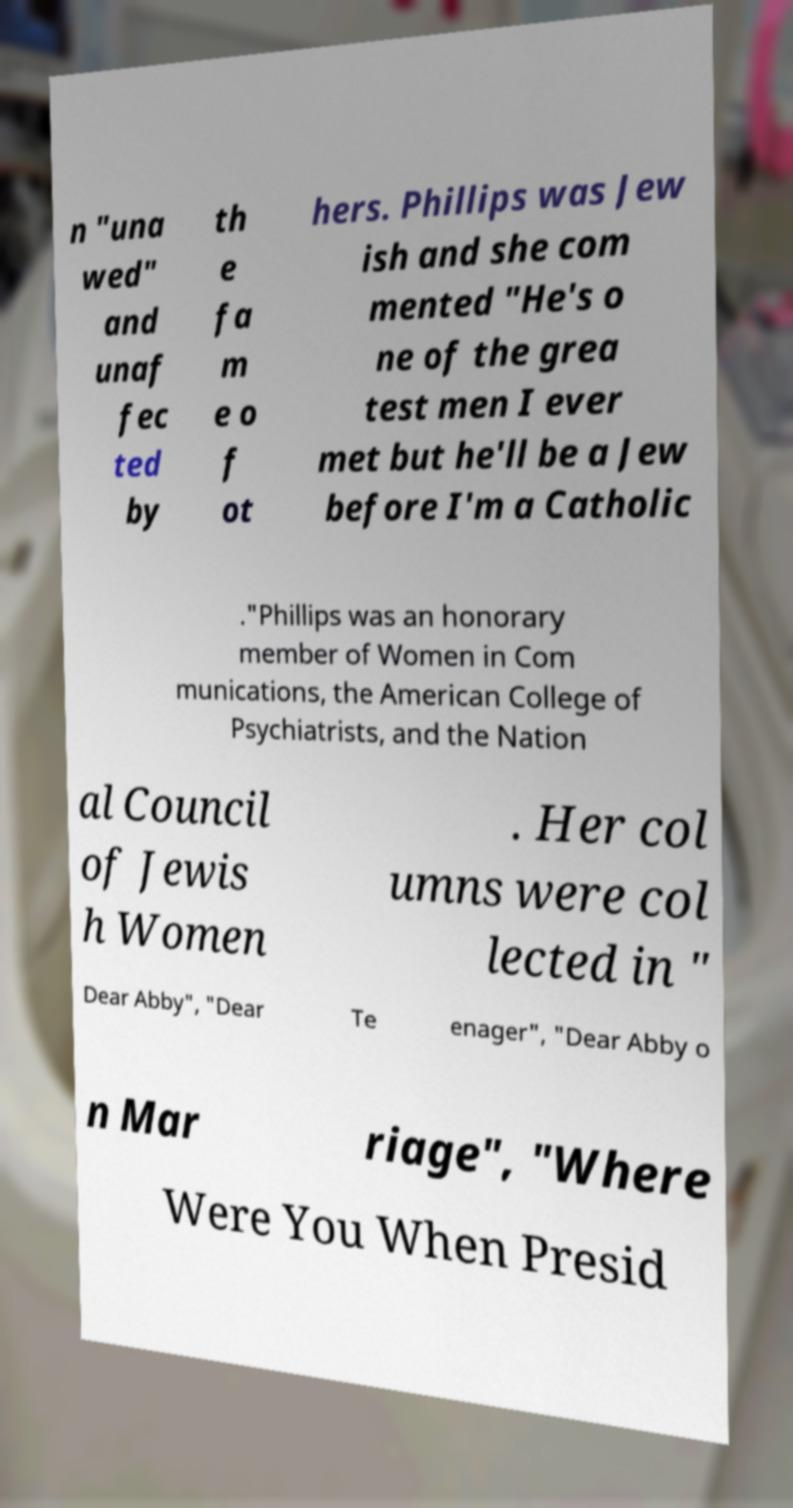Please read and relay the text visible in this image. What does it say? n "una wed" and unaf fec ted by th e fa m e o f ot hers. Phillips was Jew ish and she com mented "He's o ne of the grea test men I ever met but he'll be a Jew before I'm a Catholic ."Phillips was an honorary member of Women in Com munications, the American College of Psychiatrists, and the Nation al Council of Jewis h Women . Her col umns were col lected in " Dear Abby", "Dear Te enager", "Dear Abby o n Mar riage", "Where Were You When Presid 